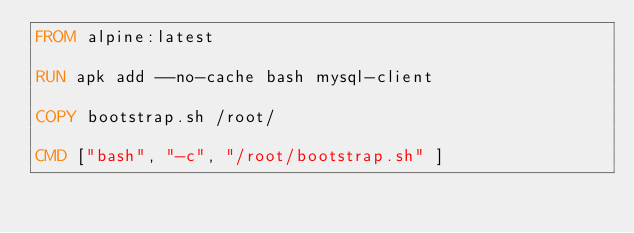<code> <loc_0><loc_0><loc_500><loc_500><_Dockerfile_>FROM alpine:latest

RUN apk add --no-cache bash mysql-client

COPY bootstrap.sh /root/

CMD ["bash", "-c", "/root/bootstrap.sh" ]</code> 